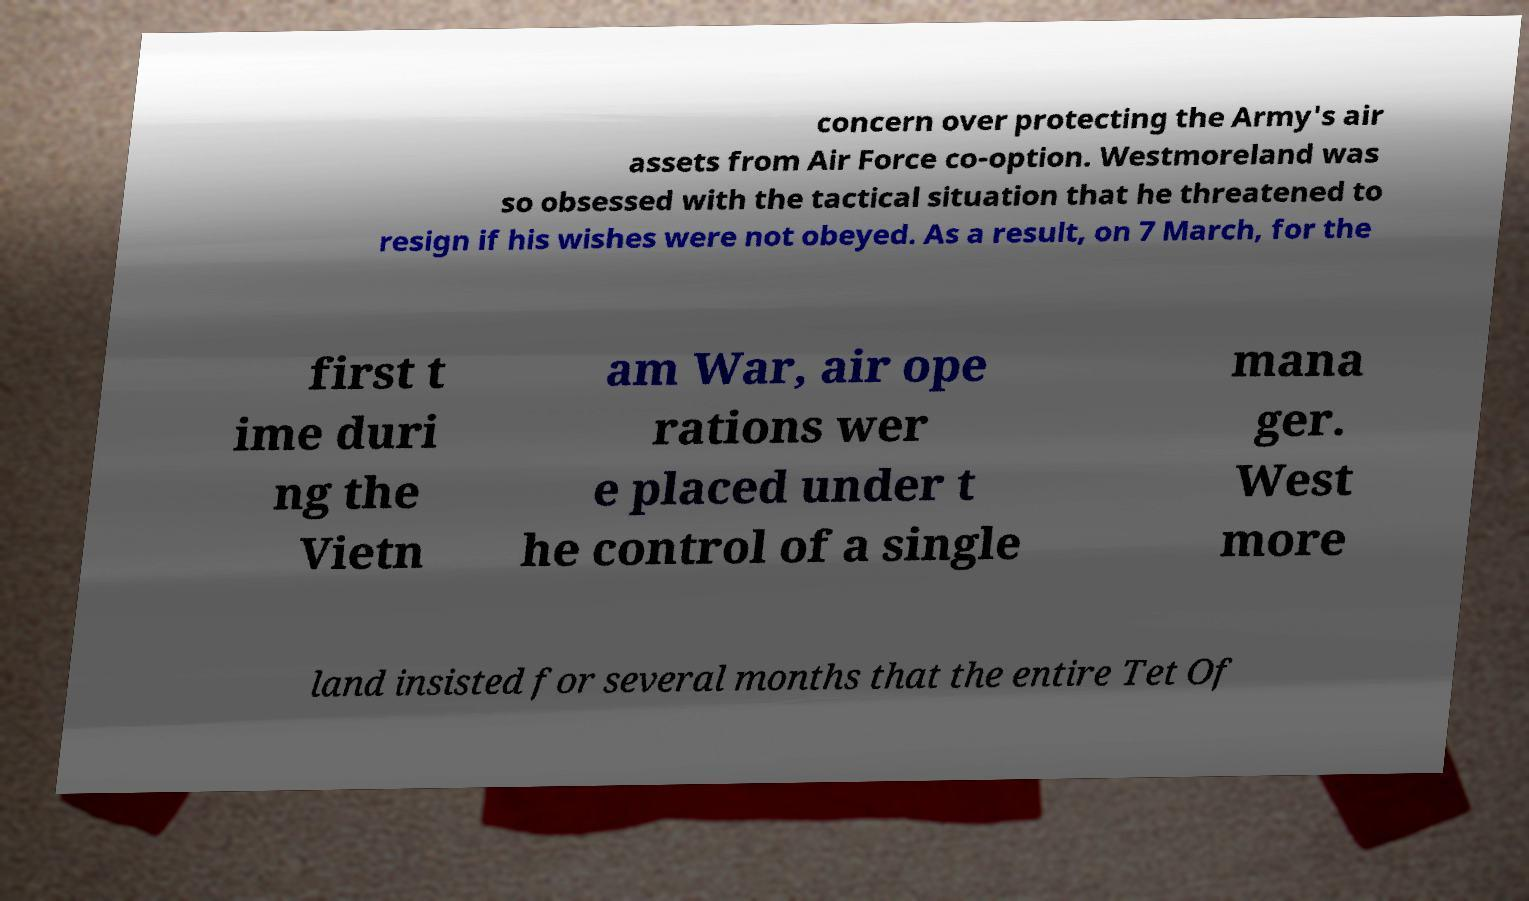Could you assist in decoding the text presented in this image and type it out clearly? concern over protecting the Army's air assets from Air Force co-option. Westmoreland was so obsessed with the tactical situation that he threatened to resign if his wishes were not obeyed. As a result, on 7 March, for the first t ime duri ng the Vietn am War, air ope rations wer e placed under t he control of a single mana ger. West more land insisted for several months that the entire Tet Of 